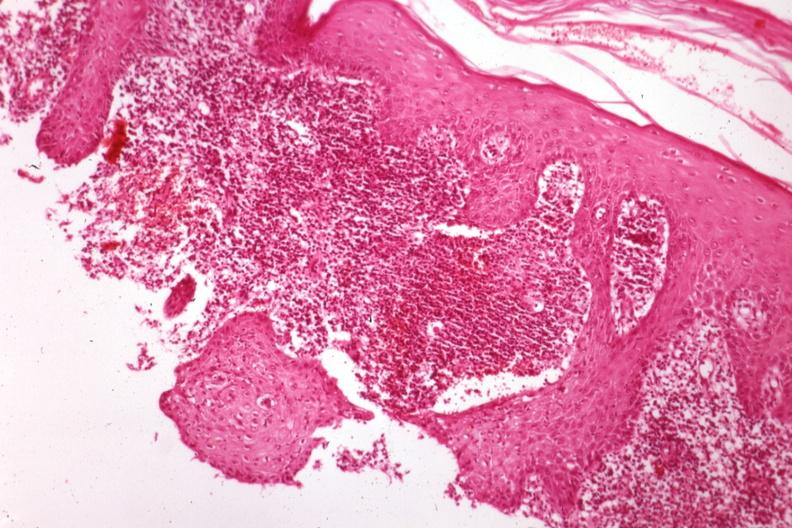where is this?
Answer the question using a single word or phrase. Skin 